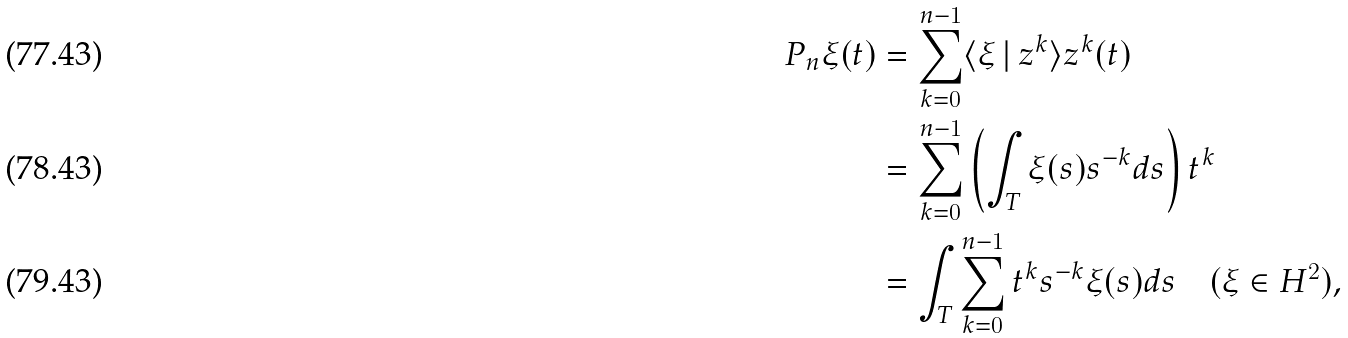<formula> <loc_0><loc_0><loc_500><loc_500>P _ { n } \xi ( t ) & = \sum _ { k = 0 } ^ { n - 1 } \langle \xi \, | \, z ^ { k } \rangle z ^ { k } ( t ) \\ & = \sum _ { k = 0 } ^ { n - 1 } \left ( \int _ { T } \xi ( s ) s ^ { - k } d s \right ) t ^ { k } \\ & = \int _ { T } \sum _ { k = 0 } ^ { n - 1 } t ^ { k } s ^ { - k } \xi ( s ) d s \quad ( \xi \in H ^ { 2 } ) ,</formula> 